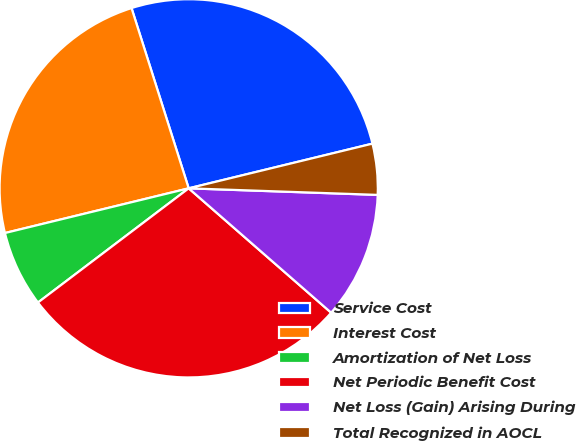<chart> <loc_0><loc_0><loc_500><loc_500><pie_chart><fcel>Service Cost<fcel>Interest Cost<fcel>Amortization of Net Loss<fcel>Net Periodic Benefit Cost<fcel>Net Loss (Gain) Arising During<fcel>Total Recognized in AOCL<nl><fcel>26.09%<fcel>23.91%<fcel>6.52%<fcel>28.26%<fcel>10.87%<fcel>4.35%<nl></chart> 